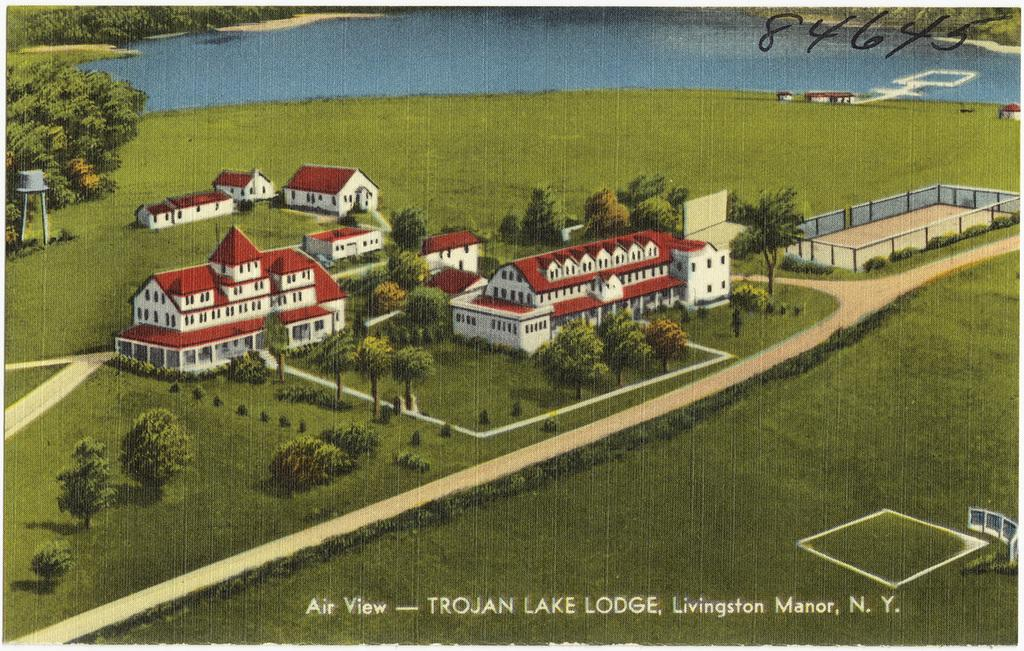What is depicted on the poster in the image? The poster contains trees, buildings, grass, and water. Are there any textual elements on the poster? Yes, there are numbers and words on the poster. Can you tell me how many lakes are shown on the poster? There is no lake depicted on the poster; it features trees, buildings, grass, and water. Is there a representative from the local government on the poster? There is no person, including a representative, present on the poster; it only contains images of trees, buildings, grass, and water, along with numbers and words. 